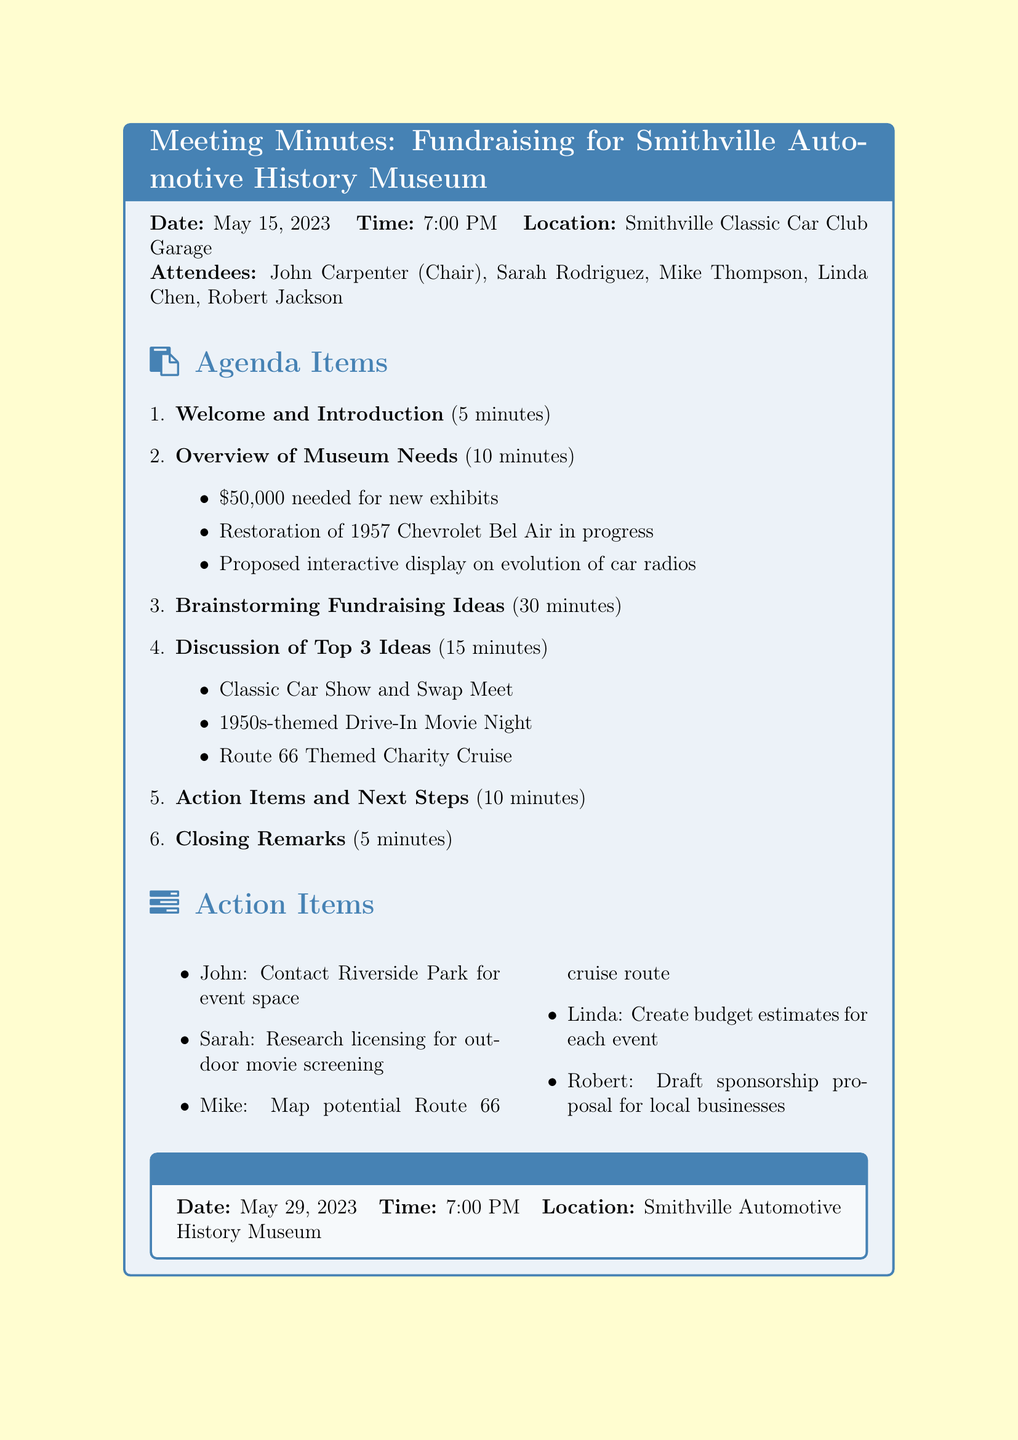What is the date of the meeting? The document specifies the date of the meeting held at the Smithville Classic Car Club Garage.
Answer: May 15, 2023 Who was the chair of the meeting? The document lists John Carpenter as the Chair of the meeting.
Answer: John Carpenter What is the total funding needed for the museum? The document mentions that the museum needs $50,000 for new exhibits.
Answer: $50,000 Which fundraising idea focuses on vintage cars? The document lists multiple fundraising ideas, one of which specifically involves classic cars.
Answer: Classic Car Show and Swap Meet What is one action item assigned to Robert? The document describes the action items set forth, including a specific task for Robert.
Answer: Draft sponsorship proposal for local businesses Which event was selected as one of the top three ideas? The document indicates three selected ideas, including a themed movie night.
Answer: 1950s-themed Drive-In Movie Night When is the next meeting scheduled? The document specifies the date and time for the next meeting following the initial one.
Answer: May 29, 2023 How long was allocated for the brainstorming session? The document outlines the agenda and specifies the duration for the brainstorming item.
Answer: 30 minutes What location is mentioned for the next meeting? The document provides details about where the next meeting will take place.
Answer: Smithville Automotive History Museum 